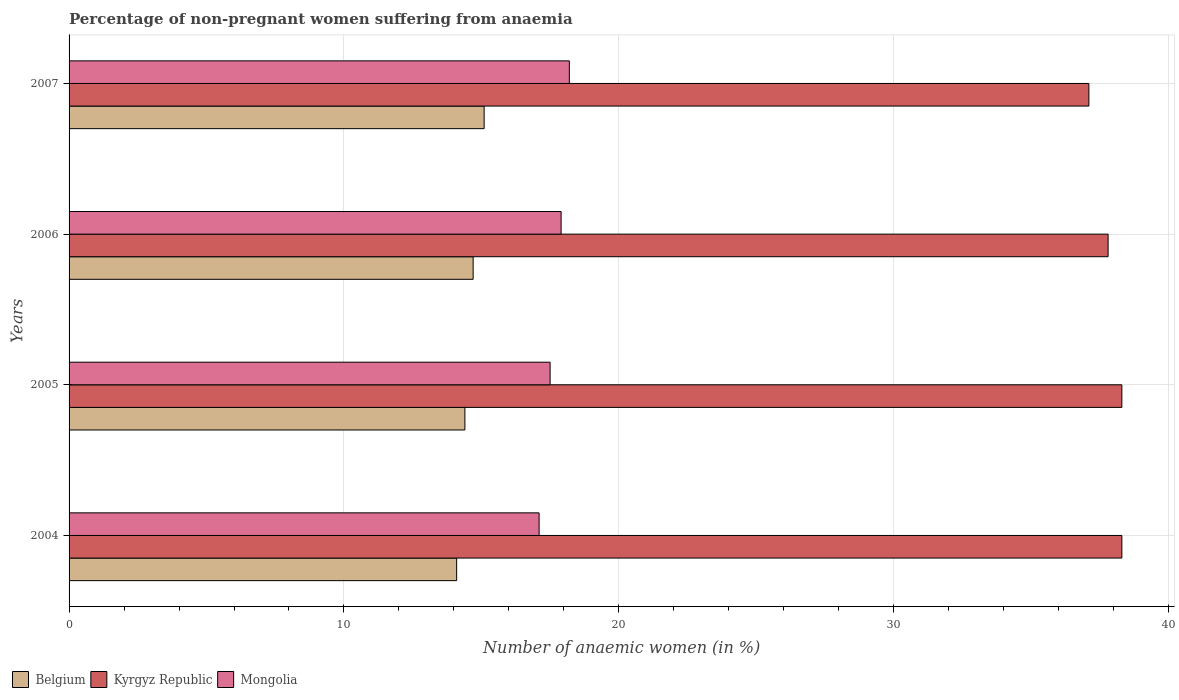How many different coloured bars are there?
Your answer should be very brief. 3. Are the number of bars per tick equal to the number of legend labels?
Your answer should be very brief. Yes. Are the number of bars on each tick of the Y-axis equal?
Provide a succinct answer. Yes. How many bars are there on the 4th tick from the bottom?
Provide a short and direct response. 3. What is the label of the 2nd group of bars from the top?
Your response must be concise. 2006. Across all years, what is the maximum percentage of non-pregnant women suffering from anaemia in Belgium?
Your answer should be compact. 15.1. Across all years, what is the minimum percentage of non-pregnant women suffering from anaemia in Belgium?
Provide a succinct answer. 14.1. What is the total percentage of non-pregnant women suffering from anaemia in Mongolia in the graph?
Offer a terse response. 70.7. What is the difference between the percentage of non-pregnant women suffering from anaemia in Kyrgyz Republic in 2006 and that in 2007?
Your answer should be very brief. 0.7. What is the difference between the percentage of non-pregnant women suffering from anaemia in Mongolia in 2006 and the percentage of non-pregnant women suffering from anaemia in Belgium in 2005?
Offer a terse response. 3.5. What is the average percentage of non-pregnant women suffering from anaemia in Kyrgyz Republic per year?
Provide a succinct answer. 37.88. In the year 2006, what is the difference between the percentage of non-pregnant women suffering from anaemia in Mongolia and percentage of non-pregnant women suffering from anaemia in Belgium?
Ensure brevity in your answer.  3.2. In how many years, is the percentage of non-pregnant women suffering from anaemia in Kyrgyz Republic greater than 24 %?
Provide a short and direct response. 4. What is the ratio of the percentage of non-pregnant women suffering from anaemia in Kyrgyz Republic in 2006 to that in 2007?
Your response must be concise. 1.02. What is the difference between the highest and the second highest percentage of non-pregnant women suffering from anaemia in Kyrgyz Republic?
Keep it short and to the point. 0. In how many years, is the percentage of non-pregnant women suffering from anaemia in Mongolia greater than the average percentage of non-pregnant women suffering from anaemia in Mongolia taken over all years?
Offer a very short reply. 2. What does the 2nd bar from the top in 2004 represents?
Your answer should be compact. Kyrgyz Republic. What does the 1st bar from the bottom in 2005 represents?
Offer a terse response. Belgium. Is it the case that in every year, the sum of the percentage of non-pregnant women suffering from anaemia in Mongolia and percentage of non-pregnant women suffering from anaemia in Belgium is greater than the percentage of non-pregnant women suffering from anaemia in Kyrgyz Republic?
Offer a very short reply. No. How many bars are there?
Your response must be concise. 12. How many years are there in the graph?
Give a very brief answer. 4. What is the difference between two consecutive major ticks on the X-axis?
Provide a short and direct response. 10. Does the graph contain any zero values?
Give a very brief answer. No. Where does the legend appear in the graph?
Your answer should be compact. Bottom left. How are the legend labels stacked?
Provide a succinct answer. Horizontal. What is the title of the graph?
Offer a terse response. Percentage of non-pregnant women suffering from anaemia. Does "Jordan" appear as one of the legend labels in the graph?
Keep it short and to the point. No. What is the label or title of the X-axis?
Give a very brief answer. Number of anaemic women (in %). What is the label or title of the Y-axis?
Provide a short and direct response. Years. What is the Number of anaemic women (in %) in Kyrgyz Republic in 2004?
Provide a short and direct response. 38.3. What is the Number of anaemic women (in %) in Mongolia in 2004?
Offer a very short reply. 17.1. What is the Number of anaemic women (in %) in Kyrgyz Republic in 2005?
Ensure brevity in your answer.  38.3. What is the Number of anaemic women (in %) in Belgium in 2006?
Offer a terse response. 14.7. What is the Number of anaemic women (in %) in Kyrgyz Republic in 2006?
Offer a terse response. 37.8. What is the Number of anaemic women (in %) of Mongolia in 2006?
Provide a short and direct response. 17.9. What is the Number of anaemic women (in %) of Kyrgyz Republic in 2007?
Your answer should be very brief. 37.1. What is the Number of anaemic women (in %) in Mongolia in 2007?
Provide a succinct answer. 18.2. Across all years, what is the maximum Number of anaemic women (in %) of Belgium?
Your answer should be very brief. 15.1. Across all years, what is the maximum Number of anaemic women (in %) of Kyrgyz Republic?
Your answer should be compact. 38.3. Across all years, what is the minimum Number of anaemic women (in %) in Kyrgyz Republic?
Your answer should be compact. 37.1. Across all years, what is the minimum Number of anaemic women (in %) of Mongolia?
Make the answer very short. 17.1. What is the total Number of anaemic women (in %) of Belgium in the graph?
Provide a succinct answer. 58.3. What is the total Number of anaemic women (in %) in Kyrgyz Republic in the graph?
Offer a terse response. 151.5. What is the total Number of anaemic women (in %) of Mongolia in the graph?
Ensure brevity in your answer.  70.7. What is the difference between the Number of anaemic women (in %) of Belgium in 2004 and that in 2005?
Offer a very short reply. -0.3. What is the difference between the Number of anaemic women (in %) in Kyrgyz Republic in 2004 and that in 2005?
Give a very brief answer. 0. What is the difference between the Number of anaemic women (in %) of Mongolia in 2004 and that in 2005?
Provide a short and direct response. -0.4. What is the difference between the Number of anaemic women (in %) of Belgium in 2004 and that in 2006?
Your answer should be compact. -0.6. What is the difference between the Number of anaemic women (in %) in Kyrgyz Republic in 2004 and that in 2006?
Your response must be concise. 0.5. What is the difference between the Number of anaemic women (in %) of Mongolia in 2004 and that in 2006?
Give a very brief answer. -0.8. What is the difference between the Number of anaemic women (in %) in Belgium in 2004 and that in 2007?
Make the answer very short. -1. What is the difference between the Number of anaemic women (in %) in Kyrgyz Republic in 2004 and that in 2007?
Provide a succinct answer. 1.2. What is the difference between the Number of anaemic women (in %) in Belgium in 2005 and that in 2006?
Offer a terse response. -0.3. What is the difference between the Number of anaemic women (in %) of Mongolia in 2005 and that in 2006?
Provide a short and direct response. -0.4. What is the difference between the Number of anaemic women (in %) in Kyrgyz Republic in 2005 and that in 2007?
Offer a very short reply. 1.2. What is the difference between the Number of anaemic women (in %) of Mongolia in 2005 and that in 2007?
Your response must be concise. -0.7. What is the difference between the Number of anaemic women (in %) of Kyrgyz Republic in 2006 and that in 2007?
Ensure brevity in your answer.  0.7. What is the difference between the Number of anaemic women (in %) in Mongolia in 2006 and that in 2007?
Your answer should be very brief. -0.3. What is the difference between the Number of anaemic women (in %) of Belgium in 2004 and the Number of anaemic women (in %) of Kyrgyz Republic in 2005?
Offer a terse response. -24.2. What is the difference between the Number of anaemic women (in %) of Kyrgyz Republic in 2004 and the Number of anaemic women (in %) of Mongolia in 2005?
Ensure brevity in your answer.  20.8. What is the difference between the Number of anaemic women (in %) in Belgium in 2004 and the Number of anaemic women (in %) in Kyrgyz Republic in 2006?
Give a very brief answer. -23.7. What is the difference between the Number of anaemic women (in %) in Belgium in 2004 and the Number of anaemic women (in %) in Mongolia in 2006?
Keep it short and to the point. -3.8. What is the difference between the Number of anaemic women (in %) in Kyrgyz Republic in 2004 and the Number of anaemic women (in %) in Mongolia in 2006?
Offer a very short reply. 20.4. What is the difference between the Number of anaemic women (in %) of Belgium in 2004 and the Number of anaemic women (in %) of Mongolia in 2007?
Make the answer very short. -4.1. What is the difference between the Number of anaemic women (in %) of Kyrgyz Republic in 2004 and the Number of anaemic women (in %) of Mongolia in 2007?
Provide a short and direct response. 20.1. What is the difference between the Number of anaemic women (in %) in Belgium in 2005 and the Number of anaemic women (in %) in Kyrgyz Republic in 2006?
Your response must be concise. -23.4. What is the difference between the Number of anaemic women (in %) in Kyrgyz Republic in 2005 and the Number of anaemic women (in %) in Mongolia in 2006?
Make the answer very short. 20.4. What is the difference between the Number of anaemic women (in %) of Belgium in 2005 and the Number of anaemic women (in %) of Kyrgyz Republic in 2007?
Your answer should be very brief. -22.7. What is the difference between the Number of anaemic women (in %) of Kyrgyz Republic in 2005 and the Number of anaemic women (in %) of Mongolia in 2007?
Your response must be concise. 20.1. What is the difference between the Number of anaemic women (in %) of Belgium in 2006 and the Number of anaemic women (in %) of Kyrgyz Republic in 2007?
Ensure brevity in your answer.  -22.4. What is the difference between the Number of anaemic women (in %) in Kyrgyz Republic in 2006 and the Number of anaemic women (in %) in Mongolia in 2007?
Give a very brief answer. 19.6. What is the average Number of anaemic women (in %) in Belgium per year?
Your answer should be very brief. 14.57. What is the average Number of anaemic women (in %) in Kyrgyz Republic per year?
Ensure brevity in your answer.  37.88. What is the average Number of anaemic women (in %) of Mongolia per year?
Provide a short and direct response. 17.68. In the year 2004, what is the difference between the Number of anaemic women (in %) of Belgium and Number of anaemic women (in %) of Kyrgyz Republic?
Ensure brevity in your answer.  -24.2. In the year 2004, what is the difference between the Number of anaemic women (in %) in Belgium and Number of anaemic women (in %) in Mongolia?
Provide a succinct answer. -3. In the year 2004, what is the difference between the Number of anaemic women (in %) of Kyrgyz Republic and Number of anaemic women (in %) of Mongolia?
Your answer should be very brief. 21.2. In the year 2005, what is the difference between the Number of anaemic women (in %) in Belgium and Number of anaemic women (in %) in Kyrgyz Republic?
Your answer should be very brief. -23.9. In the year 2005, what is the difference between the Number of anaemic women (in %) in Belgium and Number of anaemic women (in %) in Mongolia?
Ensure brevity in your answer.  -3.1. In the year 2005, what is the difference between the Number of anaemic women (in %) of Kyrgyz Republic and Number of anaemic women (in %) of Mongolia?
Your response must be concise. 20.8. In the year 2006, what is the difference between the Number of anaemic women (in %) in Belgium and Number of anaemic women (in %) in Kyrgyz Republic?
Your response must be concise. -23.1. In the year 2006, what is the difference between the Number of anaemic women (in %) of Belgium and Number of anaemic women (in %) of Mongolia?
Your answer should be very brief. -3.2. In the year 2007, what is the difference between the Number of anaemic women (in %) of Belgium and Number of anaemic women (in %) of Kyrgyz Republic?
Provide a succinct answer. -22. In the year 2007, what is the difference between the Number of anaemic women (in %) of Belgium and Number of anaemic women (in %) of Mongolia?
Your answer should be very brief. -3.1. In the year 2007, what is the difference between the Number of anaemic women (in %) of Kyrgyz Republic and Number of anaemic women (in %) of Mongolia?
Your response must be concise. 18.9. What is the ratio of the Number of anaemic women (in %) of Belgium in 2004 to that in 2005?
Keep it short and to the point. 0.98. What is the ratio of the Number of anaemic women (in %) of Kyrgyz Republic in 2004 to that in 2005?
Your answer should be very brief. 1. What is the ratio of the Number of anaemic women (in %) in Mongolia in 2004 to that in 2005?
Your answer should be very brief. 0.98. What is the ratio of the Number of anaemic women (in %) in Belgium in 2004 to that in 2006?
Make the answer very short. 0.96. What is the ratio of the Number of anaemic women (in %) of Kyrgyz Republic in 2004 to that in 2006?
Make the answer very short. 1.01. What is the ratio of the Number of anaemic women (in %) in Mongolia in 2004 to that in 2006?
Offer a very short reply. 0.96. What is the ratio of the Number of anaemic women (in %) in Belgium in 2004 to that in 2007?
Offer a very short reply. 0.93. What is the ratio of the Number of anaemic women (in %) of Kyrgyz Republic in 2004 to that in 2007?
Provide a succinct answer. 1.03. What is the ratio of the Number of anaemic women (in %) of Mongolia in 2004 to that in 2007?
Offer a terse response. 0.94. What is the ratio of the Number of anaemic women (in %) of Belgium in 2005 to that in 2006?
Your answer should be compact. 0.98. What is the ratio of the Number of anaemic women (in %) of Kyrgyz Republic in 2005 to that in 2006?
Give a very brief answer. 1.01. What is the ratio of the Number of anaemic women (in %) in Mongolia in 2005 to that in 2006?
Offer a terse response. 0.98. What is the ratio of the Number of anaemic women (in %) in Belgium in 2005 to that in 2007?
Your answer should be very brief. 0.95. What is the ratio of the Number of anaemic women (in %) in Kyrgyz Republic in 2005 to that in 2007?
Give a very brief answer. 1.03. What is the ratio of the Number of anaemic women (in %) of Mongolia in 2005 to that in 2007?
Your response must be concise. 0.96. What is the ratio of the Number of anaemic women (in %) in Belgium in 2006 to that in 2007?
Your answer should be very brief. 0.97. What is the ratio of the Number of anaemic women (in %) of Kyrgyz Republic in 2006 to that in 2007?
Make the answer very short. 1.02. What is the ratio of the Number of anaemic women (in %) in Mongolia in 2006 to that in 2007?
Provide a short and direct response. 0.98. What is the difference between the highest and the second highest Number of anaemic women (in %) of Belgium?
Ensure brevity in your answer.  0.4. What is the difference between the highest and the second highest Number of anaemic women (in %) of Kyrgyz Republic?
Provide a short and direct response. 0. What is the difference between the highest and the second highest Number of anaemic women (in %) of Mongolia?
Make the answer very short. 0.3. What is the difference between the highest and the lowest Number of anaemic women (in %) of Kyrgyz Republic?
Your response must be concise. 1.2. What is the difference between the highest and the lowest Number of anaemic women (in %) of Mongolia?
Give a very brief answer. 1.1. 